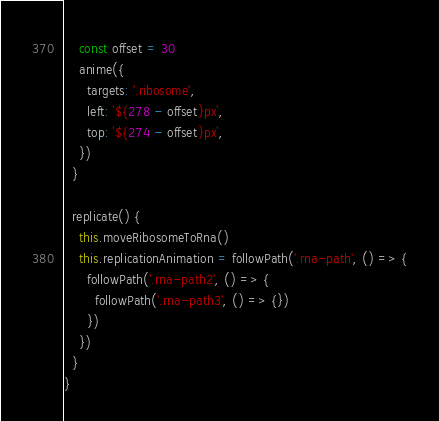Convert code to text. <code><loc_0><loc_0><loc_500><loc_500><_TypeScript_>    const offset = 30
    anime({
      targets: '.ribosome',
      left: `${278 - offset}px`,
      top: `${274 - offset}px`,
    })
  }

  replicate() {
    this.moveRibosomeToRna()
    this.replicationAnimation = followPath('.rna-path', () => {
      followPath('.rna-path2', () => {
        followPath('.rna-path3', () => {})
      })
    })
  }
}
</code> 